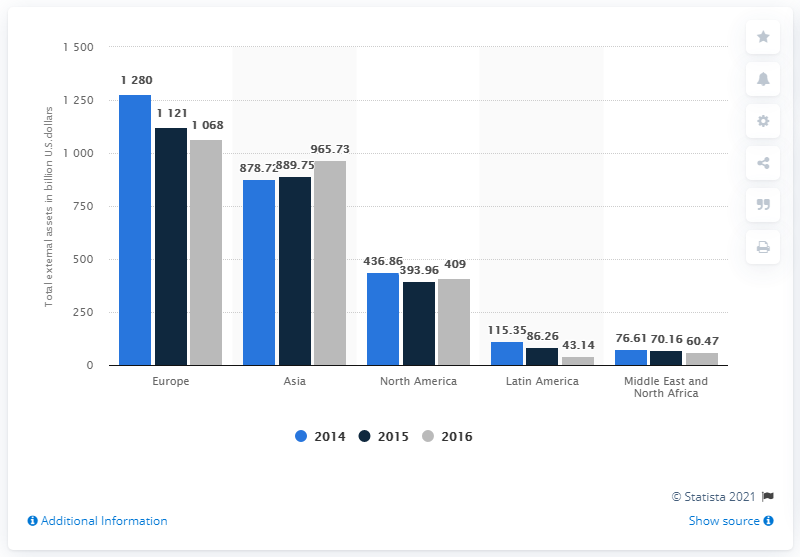Draw attention to some important aspects in this diagram. In 2015, the total external assets of HSBC bank in Europe were valued at approximately 1121 in US dollars. 